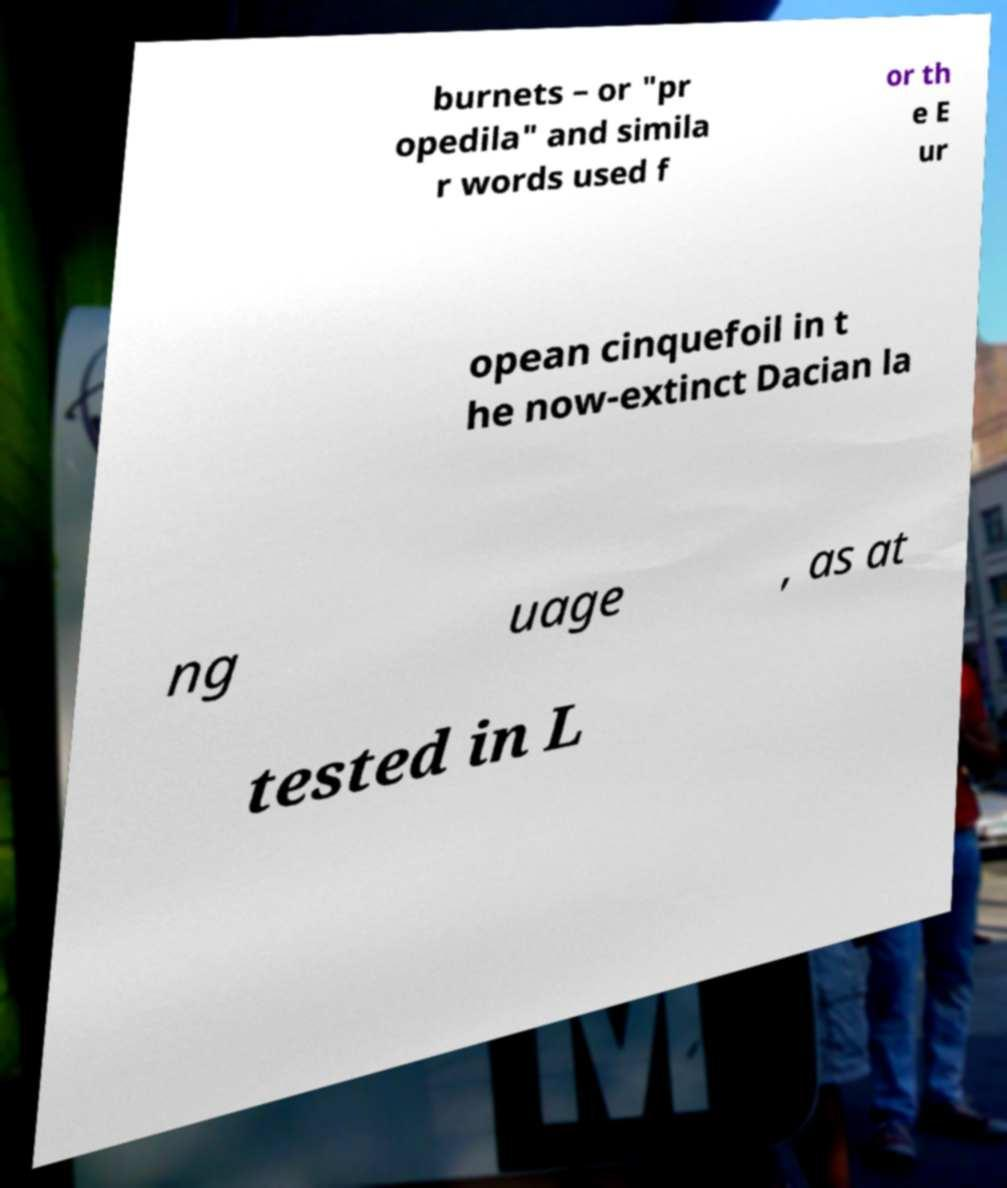Please identify and transcribe the text found in this image. burnets – or "pr opedila" and simila r words used f or th e E ur opean cinquefoil in t he now-extinct Dacian la ng uage , as at tested in L 